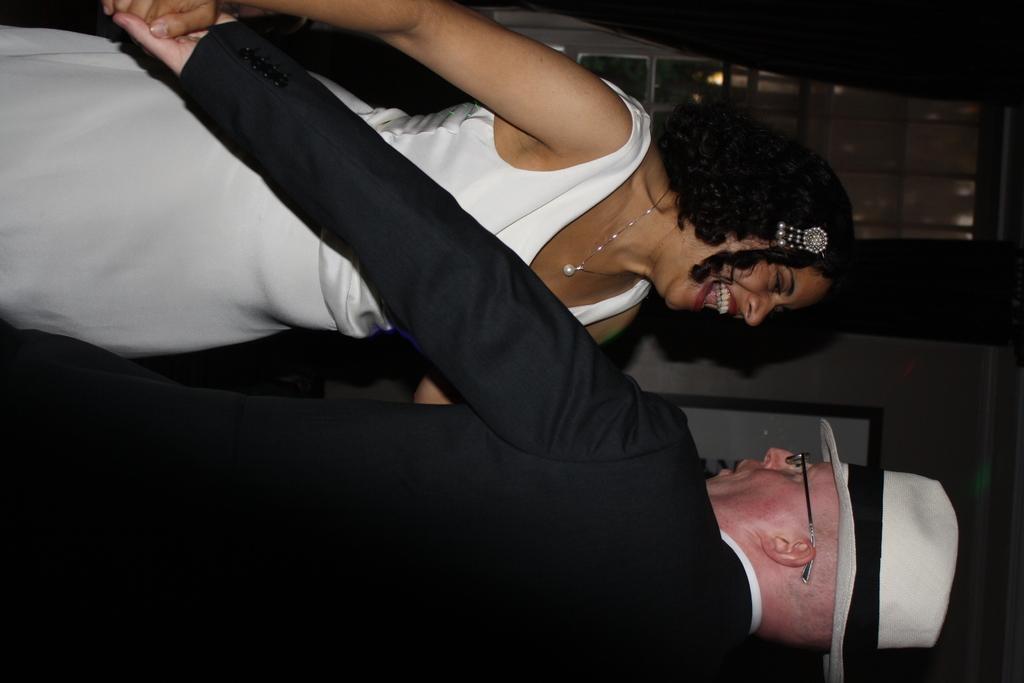Could you give a brief overview of what you see in this image? In this picture I can see a man wearing hat and holding a woman hand standing in front of him. 